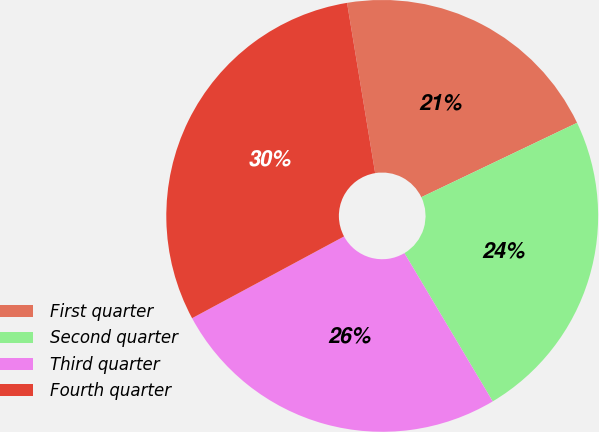<chart> <loc_0><loc_0><loc_500><loc_500><pie_chart><fcel>First quarter<fcel>Second quarter<fcel>Third quarter<fcel>Fourth quarter<nl><fcel>20.51%<fcel>23.54%<fcel>25.69%<fcel>30.25%<nl></chart> 